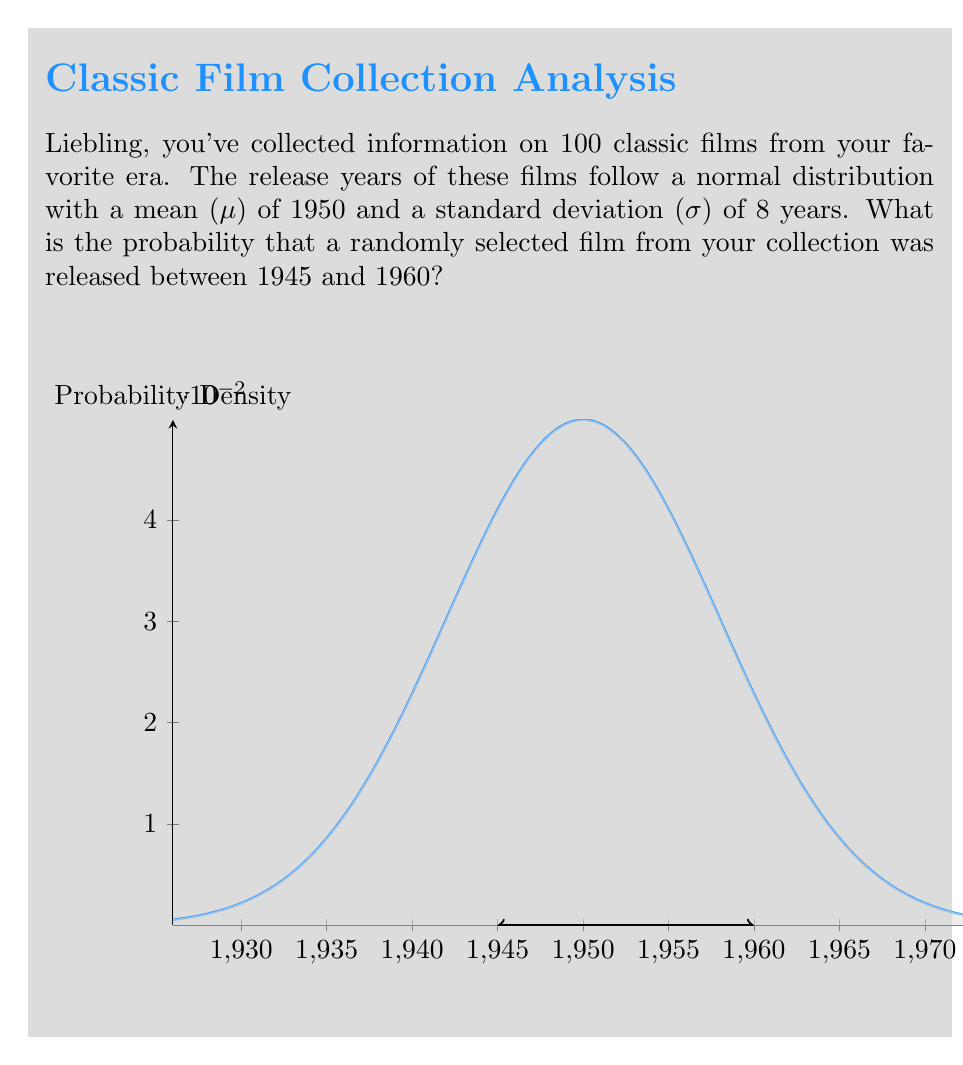Solve this math problem. Let's approach this step-by-step, meine Liebe:

1) We're dealing with a normal distribution, where:
   μ = 1950 (mean)
   σ = 8 (standard deviation)

2) We need to find P(1945 ≤ X ≤ 1960), where X is the release year.

3) To use the standard normal distribution, we need to standardize these values:
   For 1945: $z_1 = \frac{1945 - 1950}{8} = -0.625$
   For 1960: $z_2 = \frac{1960 - 1950}{8} = 1.25$

4) Now, we're looking for P(-0.625 ≤ Z ≤ 1.25), where Z is the standard normal variable.

5) Using the standard normal distribution table or a calculator:
   P(Z ≤ 1.25) = 0.8944
   P(Z ≤ -0.625) = 0.2660

6) The probability we're looking for is the difference:
   P(-0.625 ≤ Z ≤ 1.25) = P(Z ≤ 1.25) - P(Z ≤ -0.625)
                         = 0.8944 - 0.2660
                         = 0.6284

7) Therefore, the probability is approximately 0.6284 or 62.84%.
Answer: 0.6284 